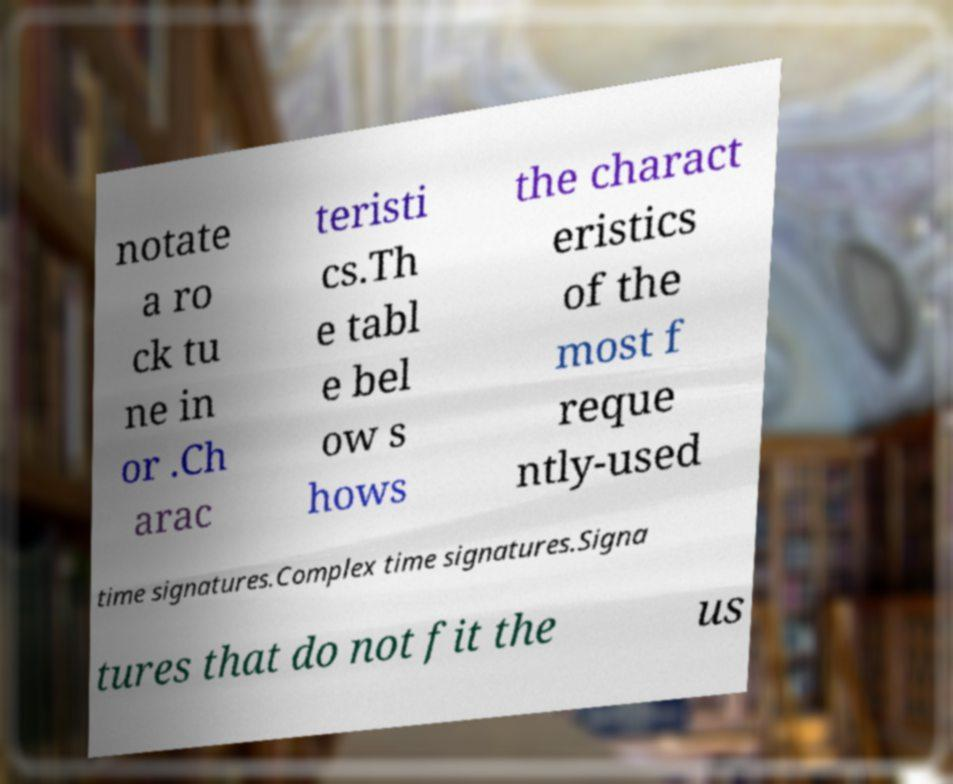For documentation purposes, I need the text within this image transcribed. Could you provide that? notate a ro ck tu ne in or .Ch arac teristi cs.Th e tabl e bel ow s hows the charact eristics of the most f reque ntly-used time signatures.Complex time signatures.Signa tures that do not fit the us 